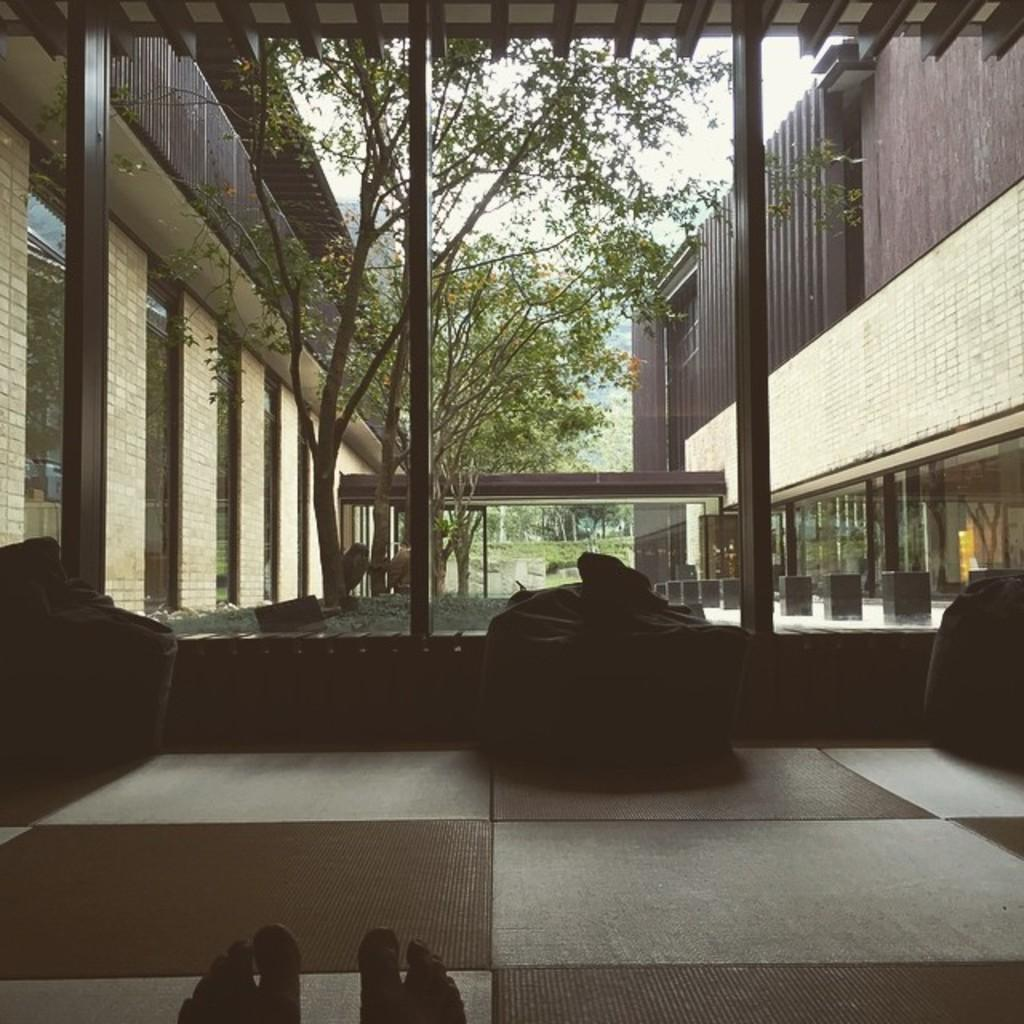What is in the room according to the image? There is a person in the room. How is the person positioned in the room? The person's legs are on the floor. How many objects are on the floor in the image? There are three objects on the floor. What can be seen in the background of the image? Trees, glass doors, a wall, a building, and the sky are visible in the background. What type of rings can be seen on the person's fingers in the image? There are no rings visible on the person's fingers in the image. What kind of apparatus is being used by the person in the image? There is no apparatus visible in the image; the person is simply standing with their legs on the floor. 